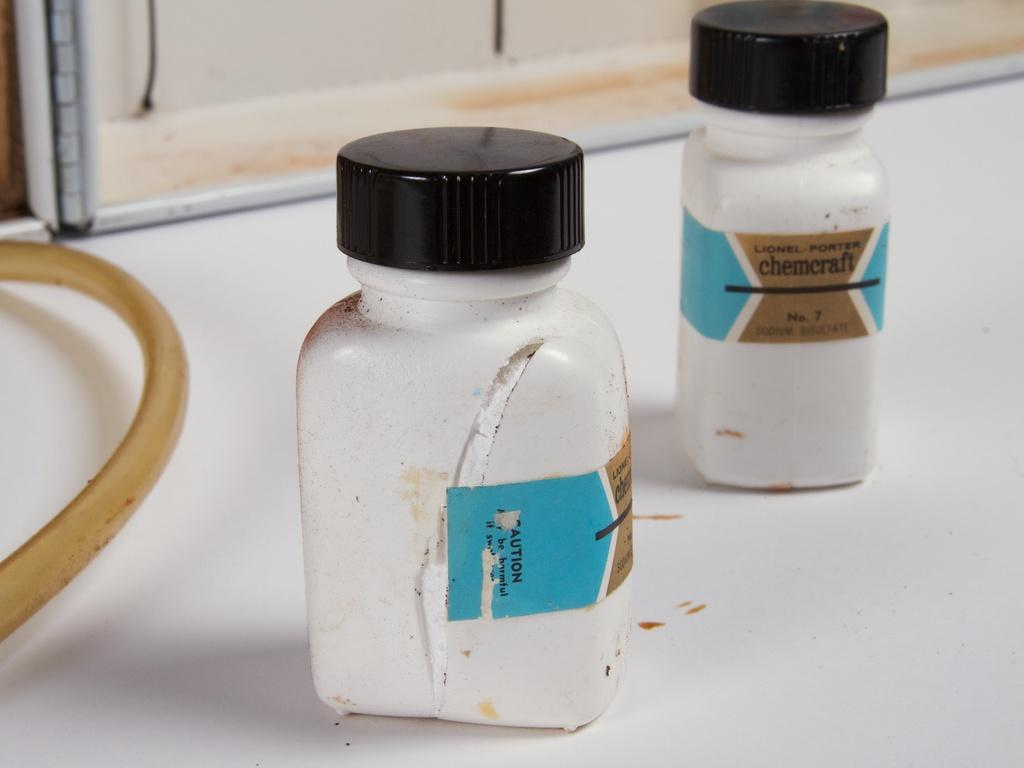<image>
Create a compact narrative representing the image presented. Two white containers of chemcraft with lids still on 